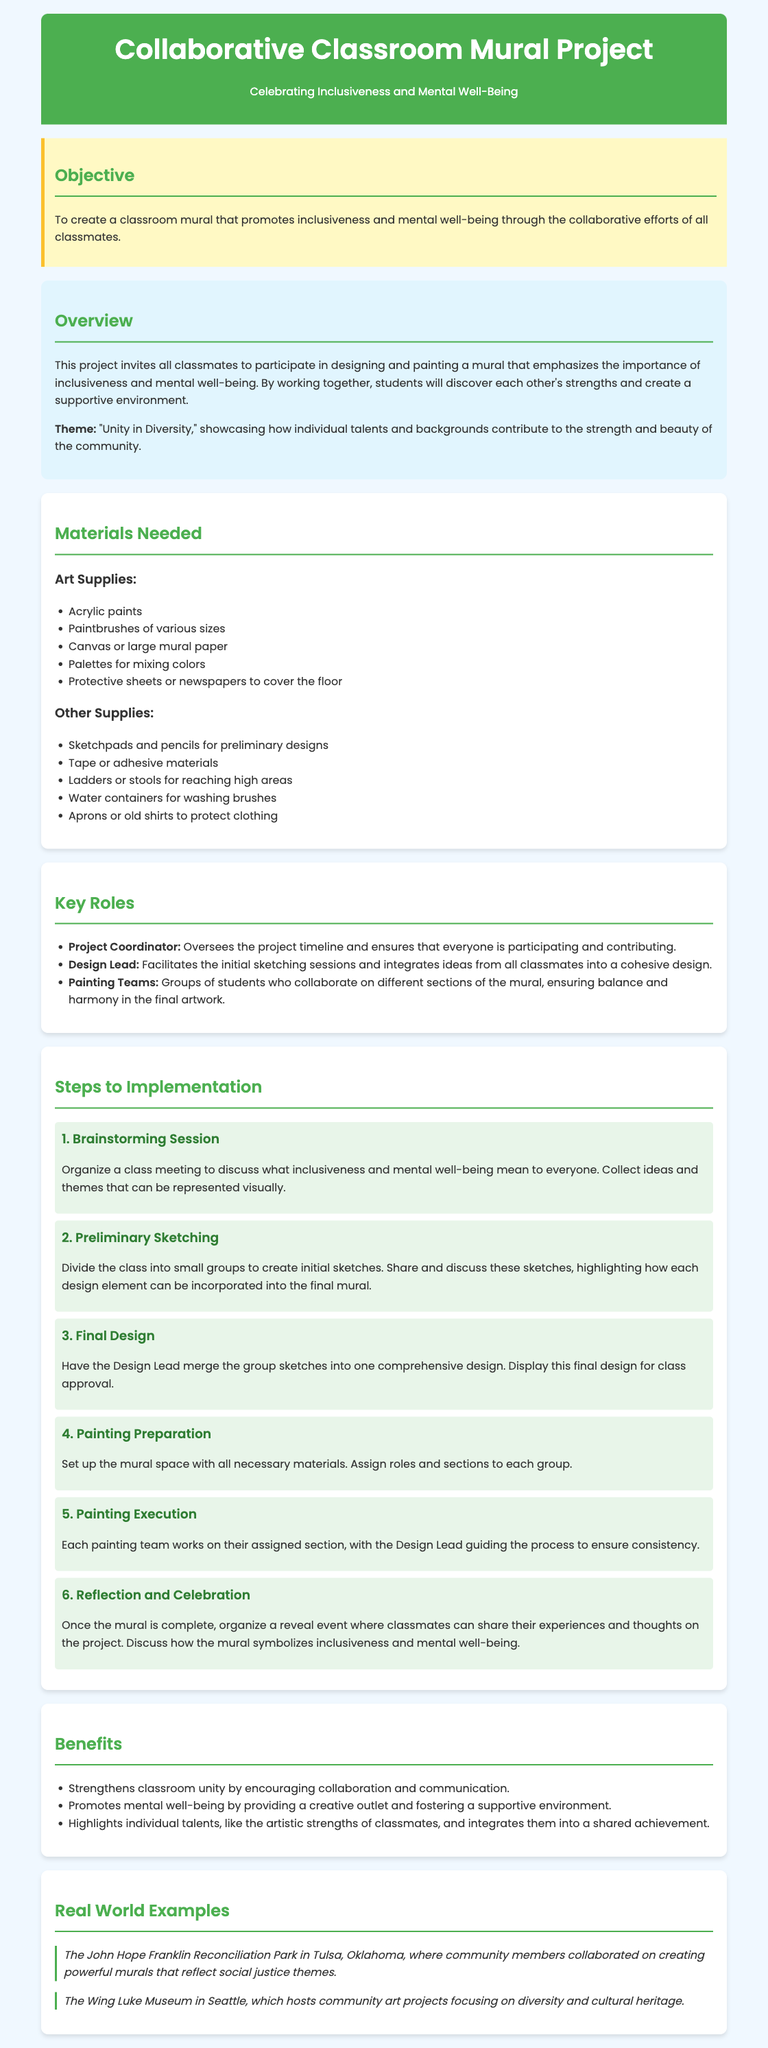What is the main objective of the project? The objective of the project is to create a classroom mural that promotes inclusiveness and mental well-being through the collaborative efforts of all classmates.
Answer: To create a classroom mural that promotes inclusiveness and mental well-being What theme is emphasized in the mural design? The theme discussed in the overview highlights how individual talents and backgrounds contribute to the community's strength and beauty.
Answer: "Unity in Diversity" How many key roles are outlined in the document? The document lists three key roles essential for the project's organization and execution.
Answer: Three What is the first step in the implementation process? The first step involves organizing a class meeting to discuss essential themes and gathering ideas from classmates.
Answer: Brainstorming Session What materials are required for preliminary designs? The document specifies the need for sketchpads and pencils for initial design work.
Answer: Sketchpads and pencils What is one benefit mentioned about the mural project? The benefits section mentions specific positive outcomes related to class unity and mental well-being through collaboration.
Answer: Strengthens classroom unity What does the 'Reflection and Celebration' step include? This step involves organizing a reveal event to share experiences and discuss the mural's symbolism.
Answer: Organizing a reveal event What kind of art supplies are listed in the document? The primary art supplies listed include acrylic paints, paintbrushes, and canvas or large mural paper.
Answer: Acrylic paints, paintbrushes, canvas or large mural paper How does the document suggest students can discover each other’s strengths? The project emphasizes that by collaborating on the mural, students will uncover each other's skills and abilities.
Answer: By working together 